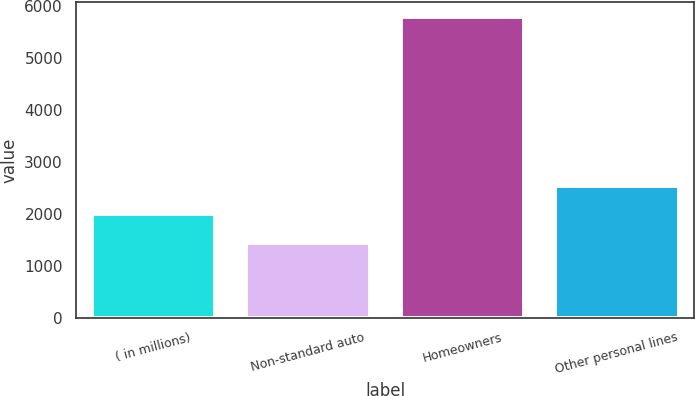<chart> <loc_0><loc_0><loc_500><loc_500><bar_chart><fcel>( in millions)<fcel>Non-standard auto<fcel>Homeowners<fcel>Other personal lines<nl><fcel>2006<fcel>1436<fcel>5793<fcel>2546<nl></chart> 